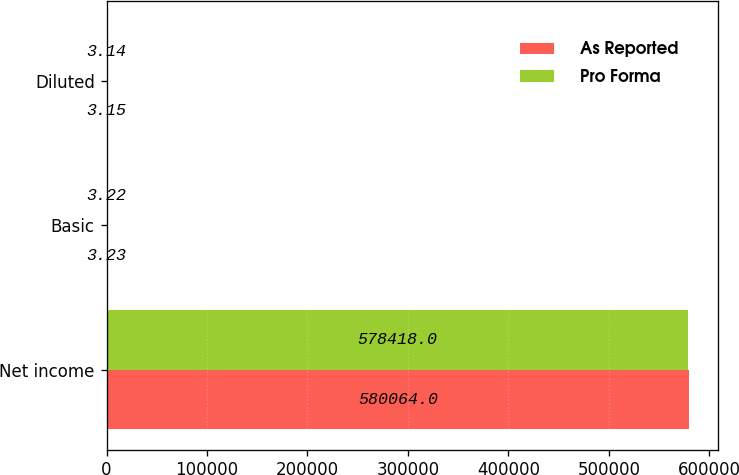Convert chart. <chart><loc_0><loc_0><loc_500><loc_500><stacked_bar_chart><ecel><fcel>Net income<fcel>Basic<fcel>Diluted<nl><fcel>As Reported<fcel>580064<fcel>3.23<fcel>3.15<nl><fcel>Pro Forma<fcel>578418<fcel>3.22<fcel>3.14<nl></chart> 